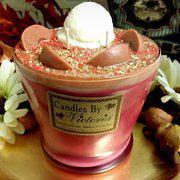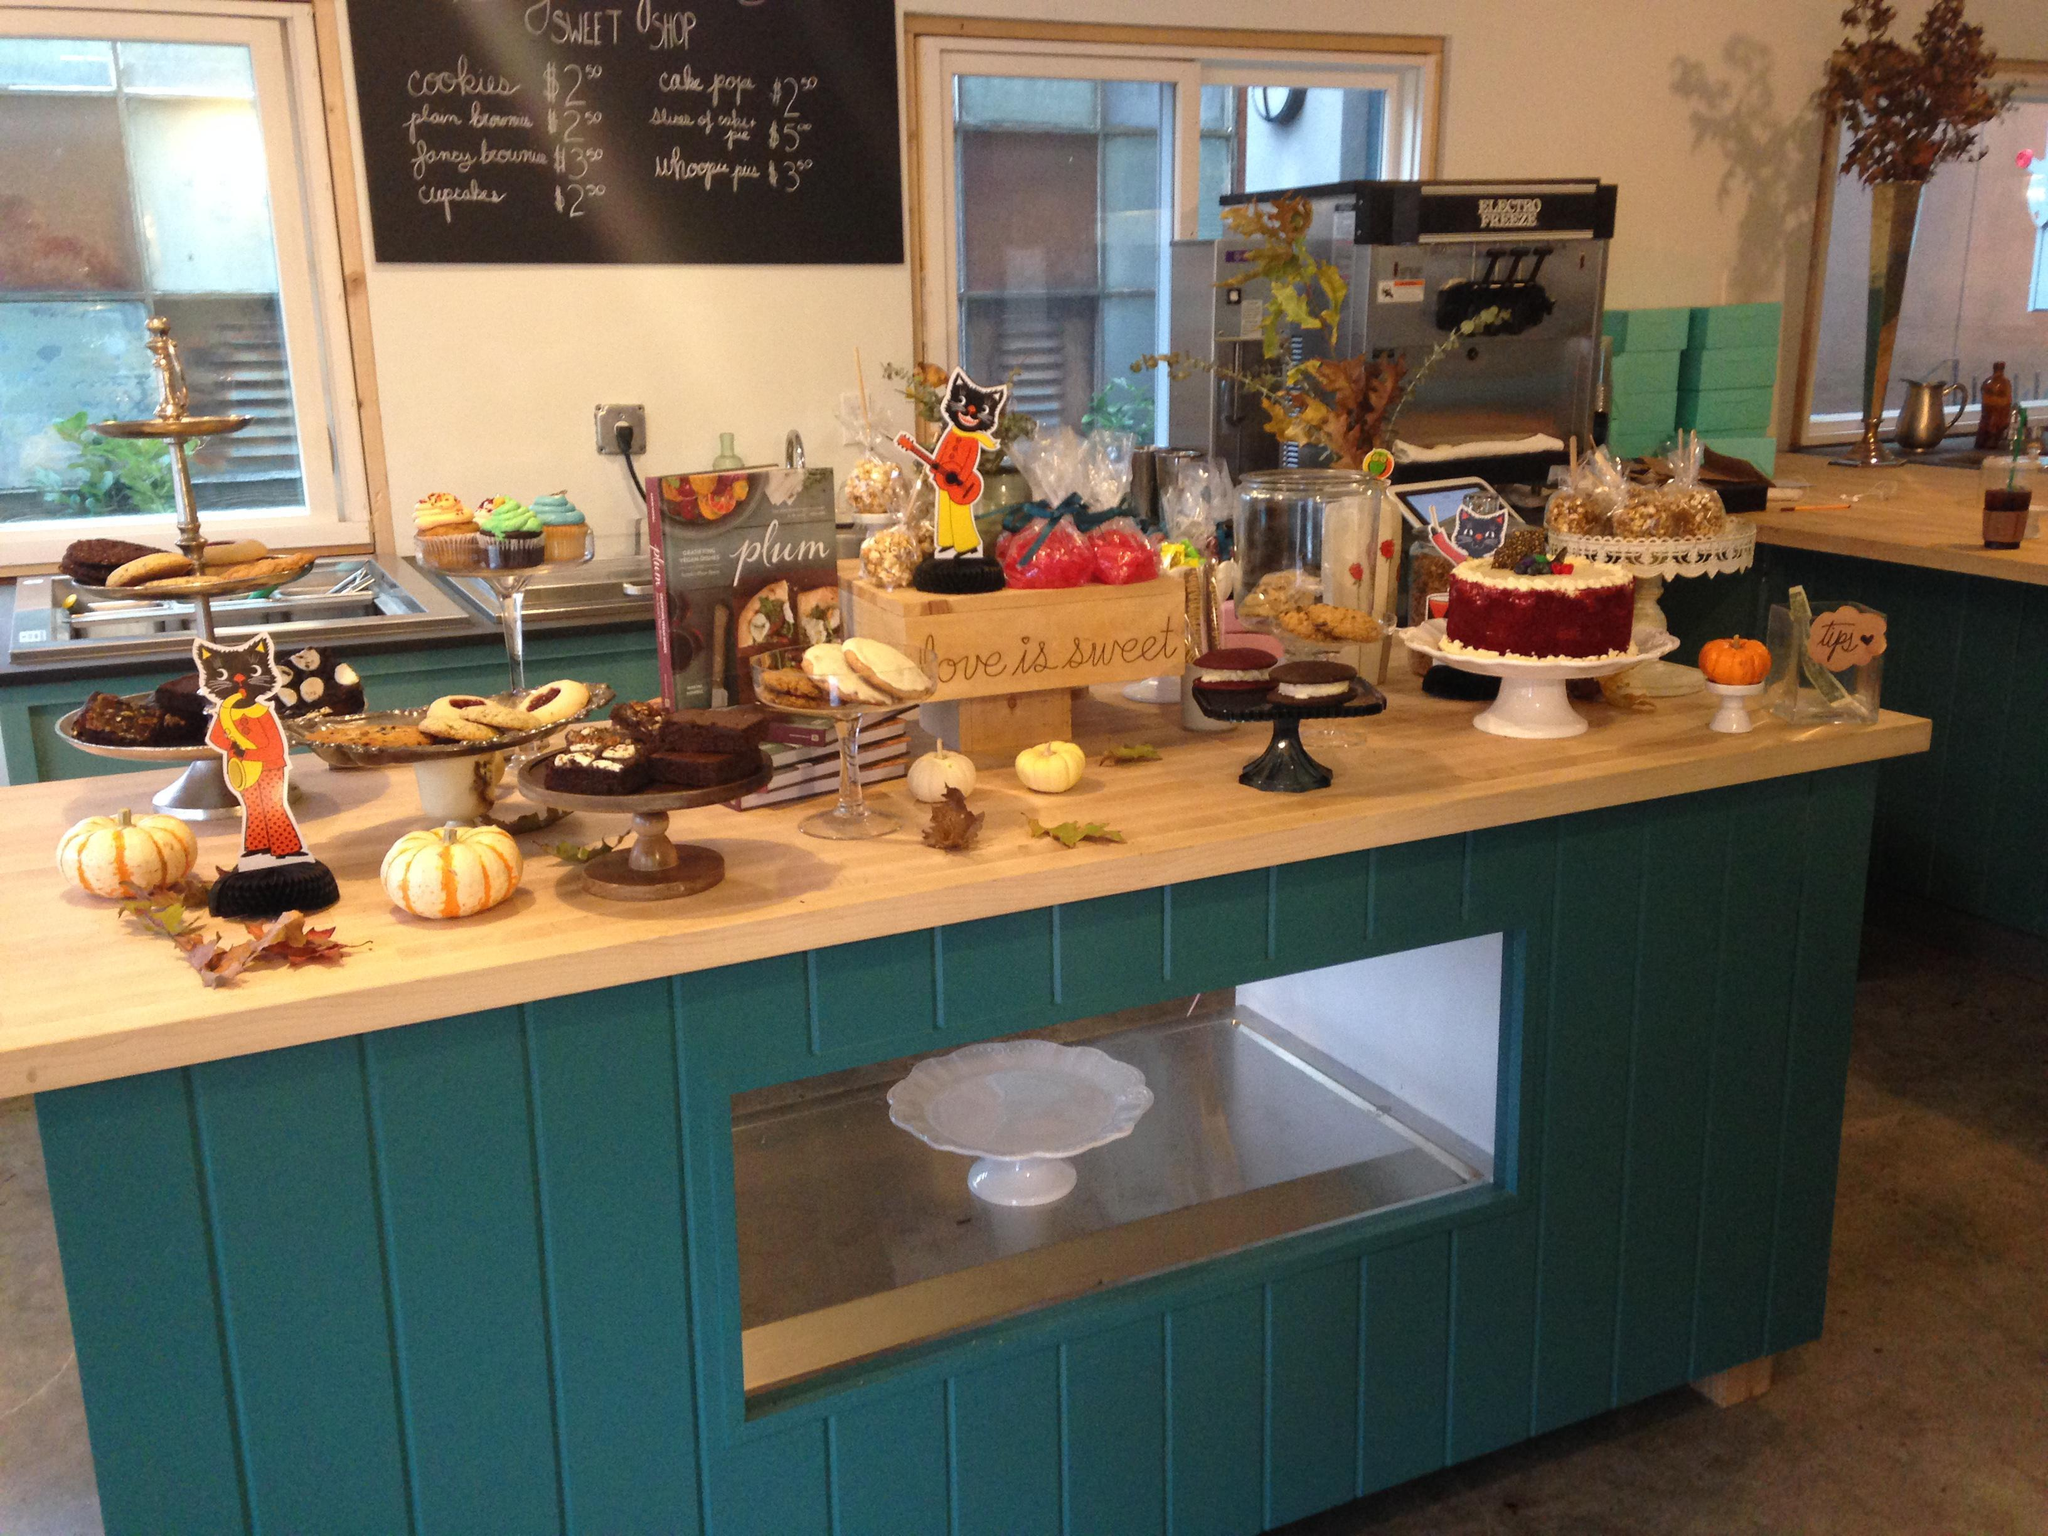The first image is the image on the left, the second image is the image on the right. Analyze the images presented: Is the assertion "In at least one image there are at least 4 strawberry slices in backed mix." valid? Answer yes or no. No. 